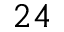<formula> <loc_0><loc_0><loc_500><loc_500>2 4</formula> 